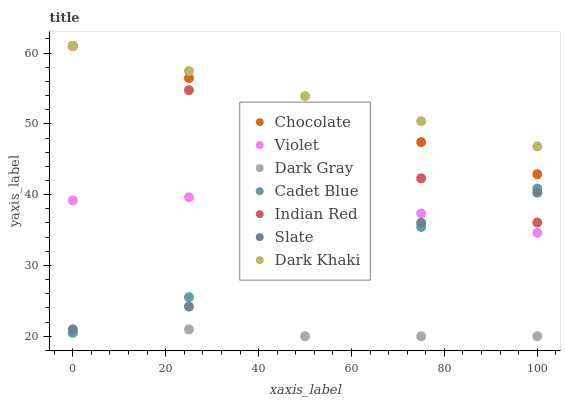Does Dark Gray have the minimum area under the curve?
Answer yes or no. Yes. Does Dark Khaki have the maximum area under the curve?
Answer yes or no. Yes. Does Cadet Blue have the minimum area under the curve?
Answer yes or no. No. Does Cadet Blue have the maximum area under the curve?
Answer yes or no. No. Is Chocolate the smoothest?
Answer yes or no. Yes. Is Cadet Blue the roughest?
Answer yes or no. Yes. Is Slate the smoothest?
Answer yes or no. No. Is Slate the roughest?
Answer yes or no. No. Does Dark Gray have the lowest value?
Answer yes or no. Yes. Does Cadet Blue have the lowest value?
Answer yes or no. No. Does Indian Red have the highest value?
Answer yes or no. Yes. Does Cadet Blue have the highest value?
Answer yes or no. No. Is Dark Gray less than Cadet Blue?
Answer yes or no. Yes. Is Indian Red greater than Violet?
Answer yes or no. Yes. Does Chocolate intersect Dark Khaki?
Answer yes or no. Yes. Is Chocolate less than Dark Khaki?
Answer yes or no. No. Is Chocolate greater than Dark Khaki?
Answer yes or no. No. Does Dark Gray intersect Cadet Blue?
Answer yes or no. No. 